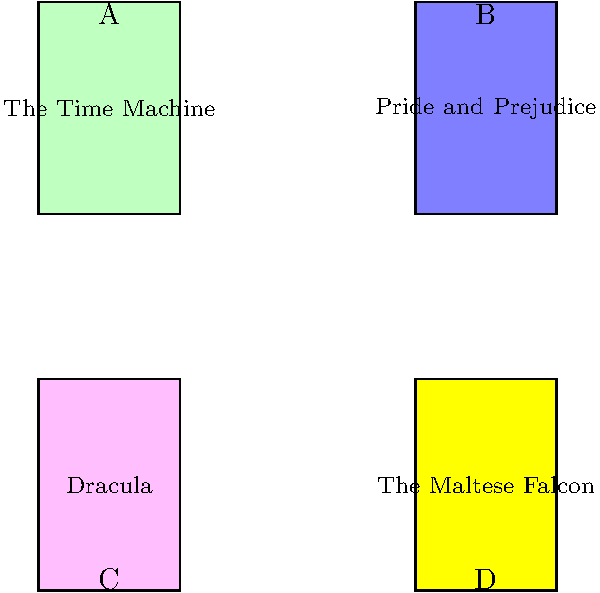Based on the book cover illustrations provided, which of these classic novels would you recommend to a young reader interested in exploring the mystery genre? To answer this question, we need to consider the genres of each book shown:

1. "The Time Machine" (A): This is a science fiction novel by H.G. Wells, involving time travel and futuristic scenarios.

2. "Pride and Prejudice" (B): This is a classic romance novel by Jane Austen, focusing on relationships and social dynamics in 19th century England.

3. "Dracula" (C): This is a gothic horror novel by Bram Stoker, featuring vampires and supernatural elements.

4. "The Maltese Falcon" (D): This is a detective novel by Dashiell Hammett, considered a classic of the hard-boiled mystery genre.

Among these options, only "The Maltese Falcon" falls squarely into the mystery genre. It features a private detective, Sam Spade, investigating a complex case involving a valuable artifact. This book would be the most suitable recommendation for a young reader interested in exploring mystery novels.
Answer: The Maltese Falcon (D) 